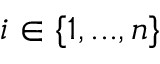Convert formula to latex. <formula><loc_0><loc_0><loc_500><loc_500>i \in \{ 1 , \dots , n \}</formula> 